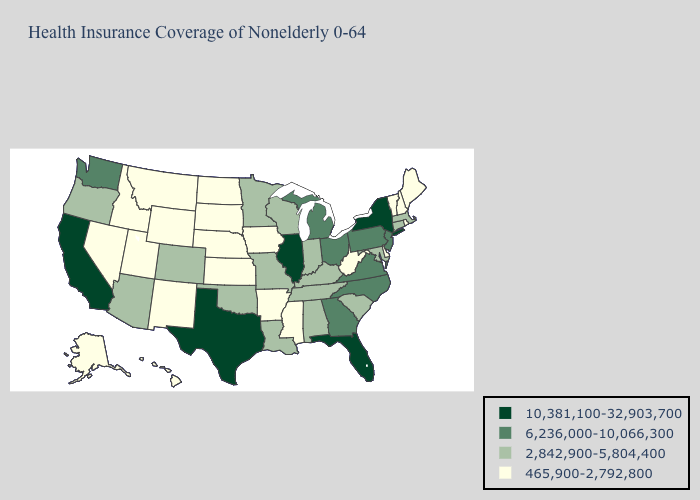Name the states that have a value in the range 10,381,100-32,903,700?
Be succinct. California, Florida, Illinois, New York, Texas. Which states have the lowest value in the West?
Write a very short answer. Alaska, Hawaii, Idaho, Montana, Nevada, New Mexico, Utah, Wyoming. What is the lowest value in states that border Kentucky?
Write a very short answer. 465,900-2,792,800. What is the lowest value in the USA?
Answer briefly. 465,900-2,792,800. Is the legend a continuous bar?
Quick response, please. No. What is the value of Texas?
Write a very short answer. 10,381,100-32,903,700. Does Illinois have the highest value in the MidWest?
Give a very brief answer. Yes. Among the states that border Colorado , which have the highest value?
Keep it brief. Arizona, Oklahoma. Name the states that have a value in the range 465,900-2,792,800?
Be succinct. Alaska, Arkansas, Delaware, Hawaii, Idaho, Iowa, Kansas, Maine, Mississippi, Montana, Nebraska, Nevada, New Hampshire, New Mexico, North Dakota, Rhode Island, South Dakota, Utah, Vermont, West Virginia, Wyoming. Name the states that have a value in the range 2,842,900-5,804,400?
Answer briefly. Alabama, Arizona, Colorado, Connecticut, Indiana, Kentucky, Louisiana, Maryland, Massachusetts, Minnesota, Missouri, Oklahoma, Oregon, South Carolina, Tennessee, Wisconsin. Among the states that border North Dakota , does Minnesota have the highest value?
Write a very short answer. Yes. Among the states that border New Hampshire , which have the lowest value?
Keep it brief. Maine, Vermont. What is the value of New Mexico?
Be succinct. 465,900-2,792,800. Name the states that have a value in the range 10,381,100-32,903,700?
Keep it brief. California, Florida, Illinois, New York, Texas. Name the states that have a value in the range 465,900-2,792,800?
Write a very short answer. Alaska, Arkansas, Delaware, Hawaii, Idaho, Iowa, Kansas, Maine, Mississippi, Montana, Nebraska, Nevada, New Hampshire, New Mexico, North Dakota, Rhode Island, South Dakota, Utah, Vermont, West Virginia, Wyoming. 